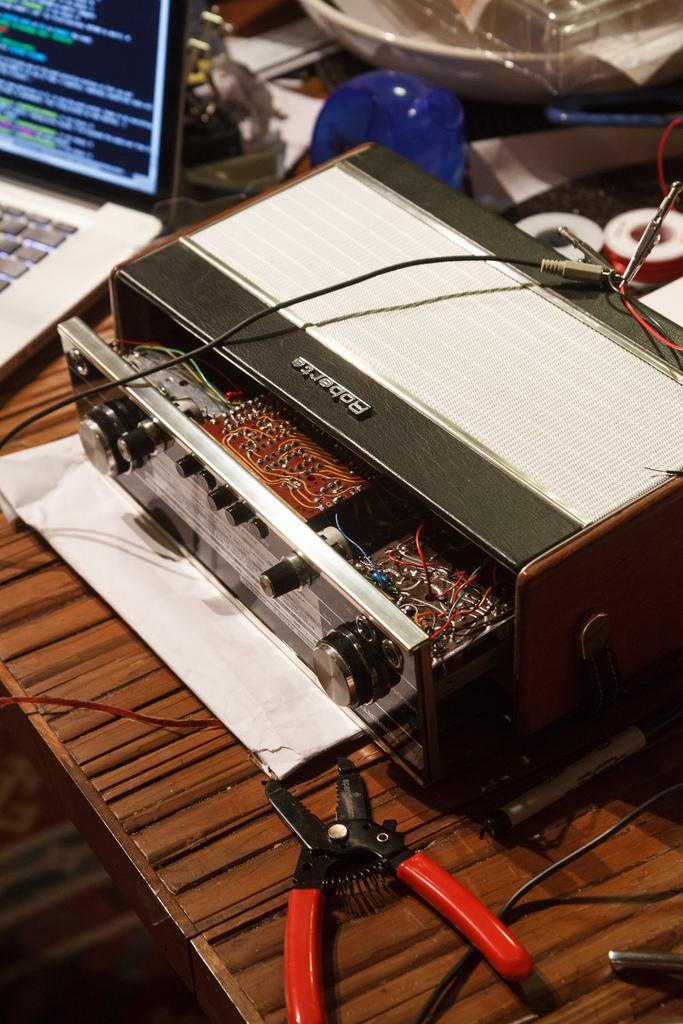What is placed on the wooden table in the image? There is a laptop, tapes, an electronic device, a cutting plier, wires, and additional objects on the wooden table. Can you describe the laptop in the image? The laptop is placed on the wooden table. What type of electronic device is on the wooden table? The electronic device is not specified, but it is on the wooden table. What tool is on the wooden table? There is a cutting plier on the wooden table. What else can be seen on the wooden table? There are wires and additional objects on the wooden table. Where is the nest of the bird in the image? There is no bird or nest present in the image; it only features a wooden table with various objects on it. 